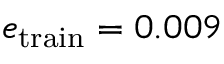<formula> <loc_0><loc_0><loc_500><loc_500>e _ { t r a i n } = 0 . 0 0 9</formula> 